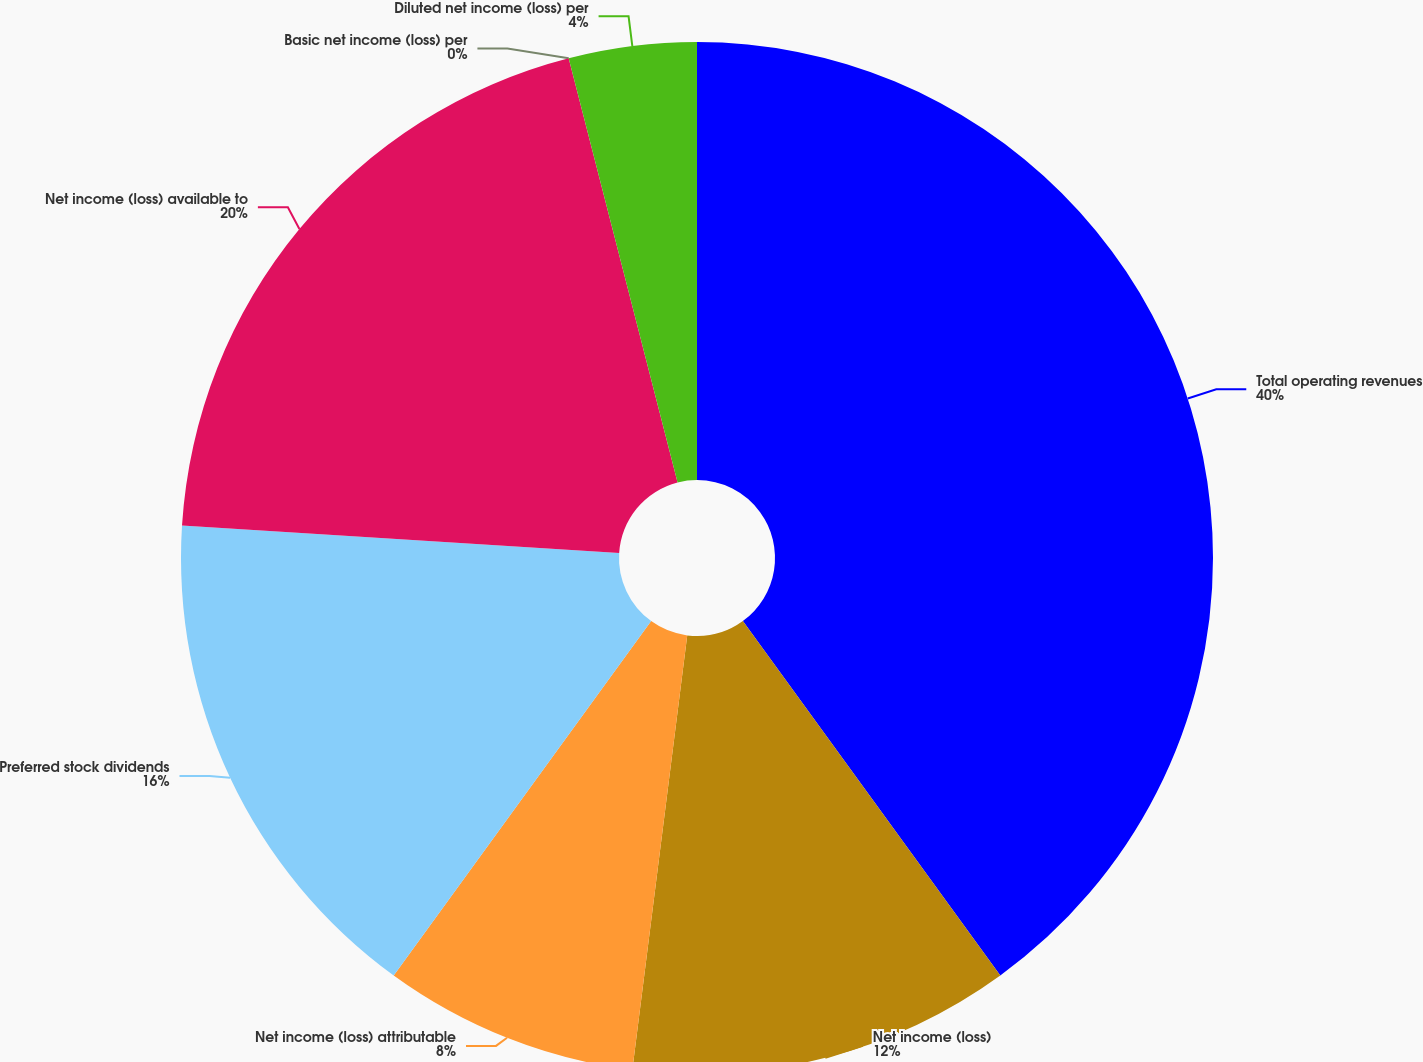Convert chart. <chart><loc_0><loc_0><loc_500><loc_500><pie_chart><fcel>Total operating revenues<fcel>Net income (loss)<fcel>Net income (loss) attributable<fcel>Preferred stock dividends<fcel>Net income (loss) available to<fcel>Basic net income (loss) per<fcel>Diluted net income (loss) per<nl><fcel>40.0%<fcel>12.0%<fcel>8.0%<fcel>16.0%<fcel>20.0%<fcel>0.0%<fcel>4.0%<nl></chart> 